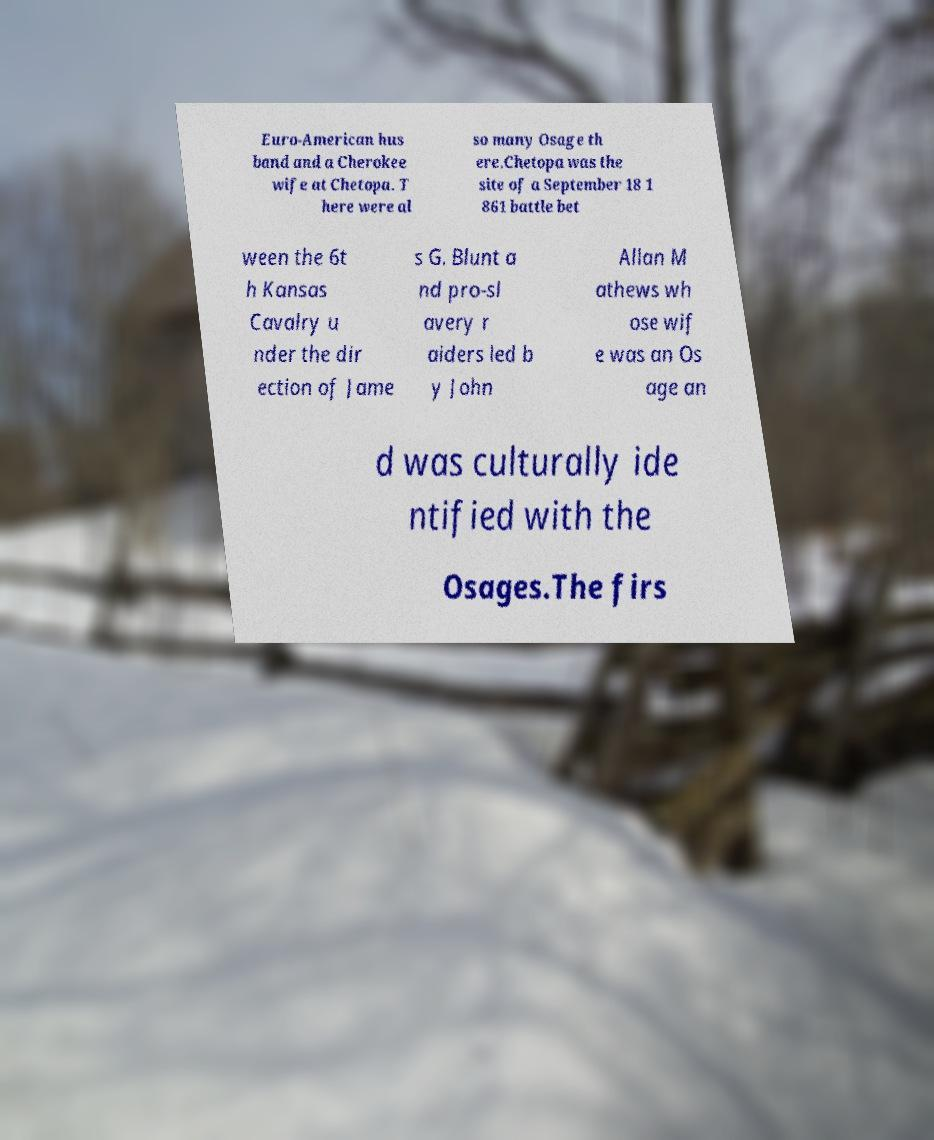Can you accurately transcribe the text from the provided image for me? Euro-American hus band and a Cherokee wife at Chetopa. T here were al so many Osage th ere.Chetopa was the site of a September 18 1 861 battle bet ween the 6t h Kansas Cavalry u nder the dir ection of Jame s G. Blunt a nd pro-sl avery r aiders led b y John Allan M athews wh ose wif e was an Os age an d was culturally ide ntified with the Osages.The firs 